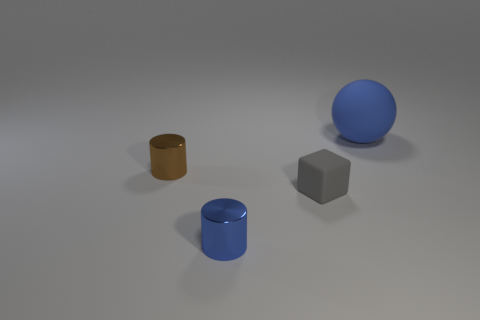Subtract all blue cylinders. How many cylinders are left? 1 Subtract all spheres. How many objects are left? 3 Add 2 gray rubber balls. How many objects exist? 6 Subtract 1 cylinders. How many cylinders are left? 1 Subtract 0 gray balls. How many objects are left? 4 Subtract all green balls. Subtract all green cylinders. How many balls are left? 1 Subtract all brown cylinders. How many purple blocks are left? 0 Subtract all large purple metallic spheres. Subtract all blue spheres. How many objects are left? 3 Add 4 big matte spheres. How many big matte spheres are left? 5 Add 1 tiny matte objects. How many tiny matte objects exist? 2 